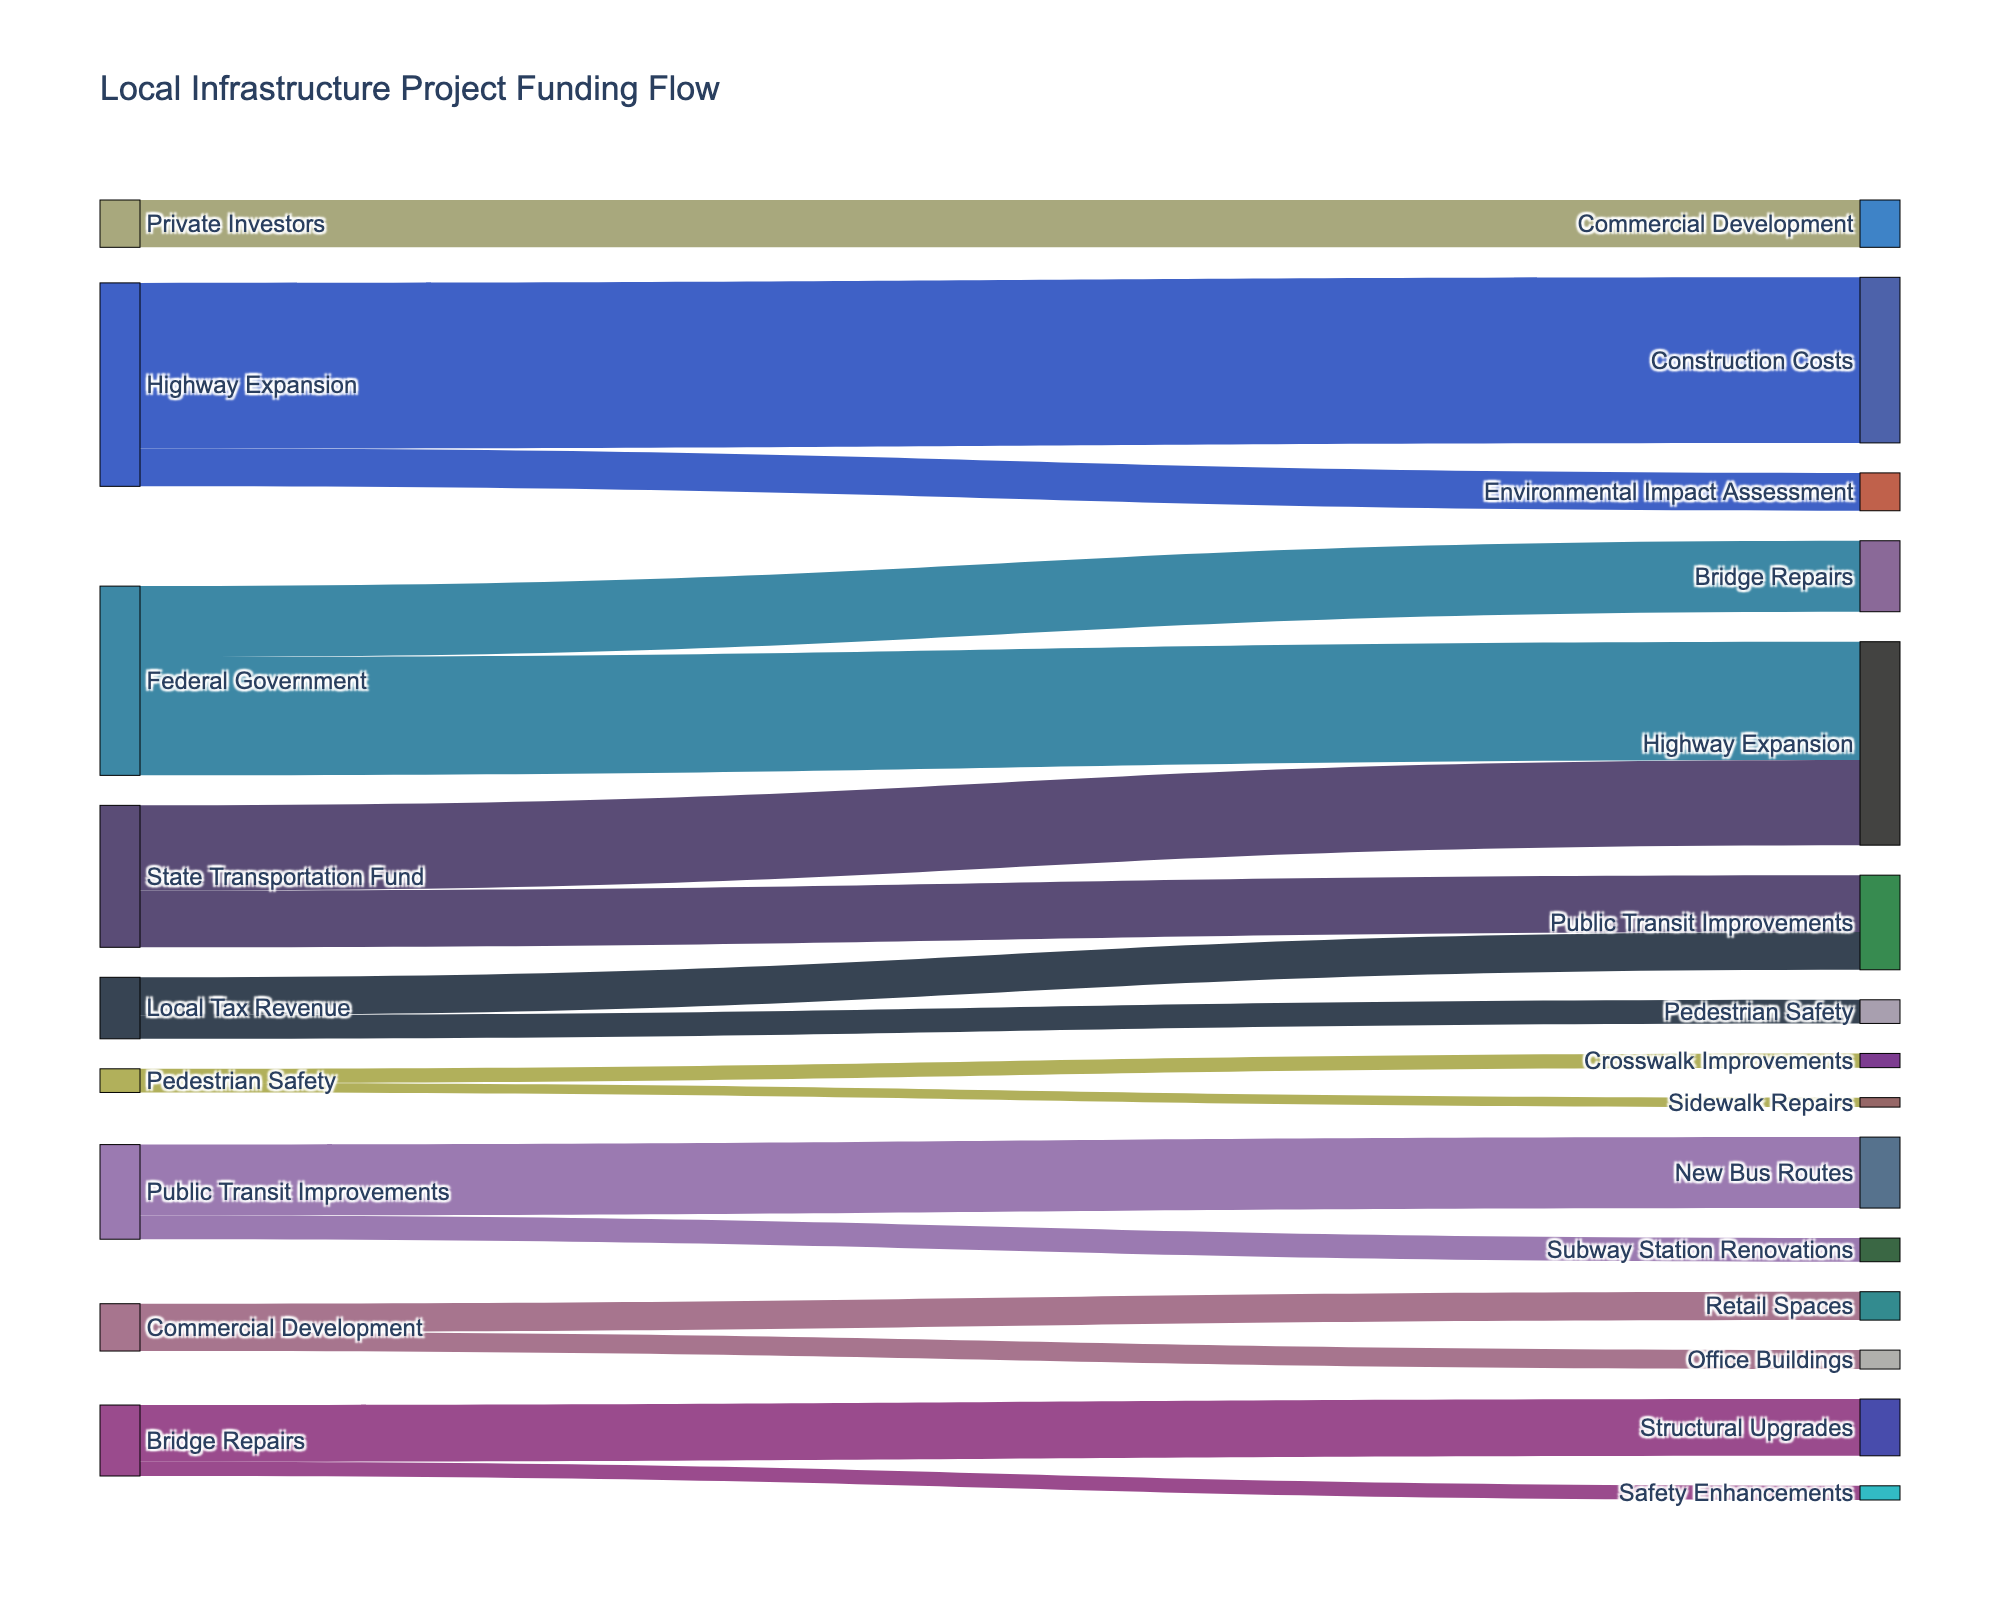Which funding source contributes the most to highway expansion? Reviewing the data, the Federal Government contributes $25,000,000, and the State Transportation Fund contributes $18,000,000. The Federal Government provides the highest contribution to highway expansion.
Answer: Federal Government What is the total amount of funding allocated to public transit improvements? Both the State Transportation Fund and Local Tax Revenue contribute to public transit improvements. Summing $12,000,000 from the State Transportation Fund and $8,000,000 from Local Tax Revenue gives us a total of $20,000,000.
Answer: $20,000,000 Which projects receive funding from the State Transportation Fund? Based on the data, the State Transportation Fund allocates $18,000,000 to Highway Expansion and $12,000,000 to Public Transit Improvements.
Answer: Highway Expansion, Public Transit Improvements How does the funding for pedestrian safety compare to commercial development? The data shows that pedestrian safety receives $5,000,000 from Local Tax Revenue, while commercial development receives $10,000,000 from private investors. Therefore, commercial development gets twice the amount allocated to pedestrian safety.
Answer: Commercial development receives more funding What are the specific allocations within the highway expansion project? The highway expansion project allocates funding to two areas: $35,000,000 for construction costs and $8,000,000 for environmental impact assessment.
Answer: Construction Costs, Environmental Impact Assessment What is the total funding from the Federal Government? Adding the Federal Government's contributions: $25,000,000 to Highway Expansion and $15,000,000 to Bridge Repairs, the total funding amounts to $40,000,000.
Answer: $40,000,000 Which project receives the least funding, and from which source? Analyzing the allocation data, the Pedestrian Safety project funded by Local Tax Revenue receives the lowest amount, with $5,000,000 in total.
Answer: Pedestrian Safety, Local Tax Revenue Out of the transit projects, which one gets the largest allocation? The Public Transit Improvements project consists of two allocations: $15,000,000 for new bus routes and $5,000,000 for subway station renovations. Within this project, new bus routes receive the largest allocation.
Answer: New Bus Routes 